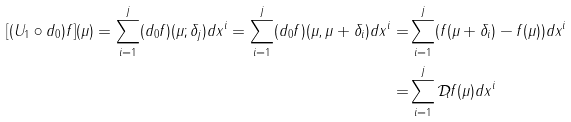<formula> <loc_0><loc_0><loc_500><loc_500>[ ( U _ { 1 } \circ d _ { 0 } ) f ] ( \mu ) = \sum _ { i = 1 } ^ { j } ( d _ { 0 } f ) ( \mu ; \delta _ { j } ) d x ^ { i } = \sum _ { i = 1 } ^ { j } ( d _ { 0 } f ) ( \mu , \mu + \delta _ { i } ) d x ^ { i } = & \sum _ { i = 1 } ^ { j } ( f ( \mu + \delta _ { i } ) - f ( \mu ) ) d x ^ { i } \\ = & \sum _ { i = 1 } ^ { j } \mathcal { D } _ { i } f ( \mu ) d x ^ { i }</formula> 